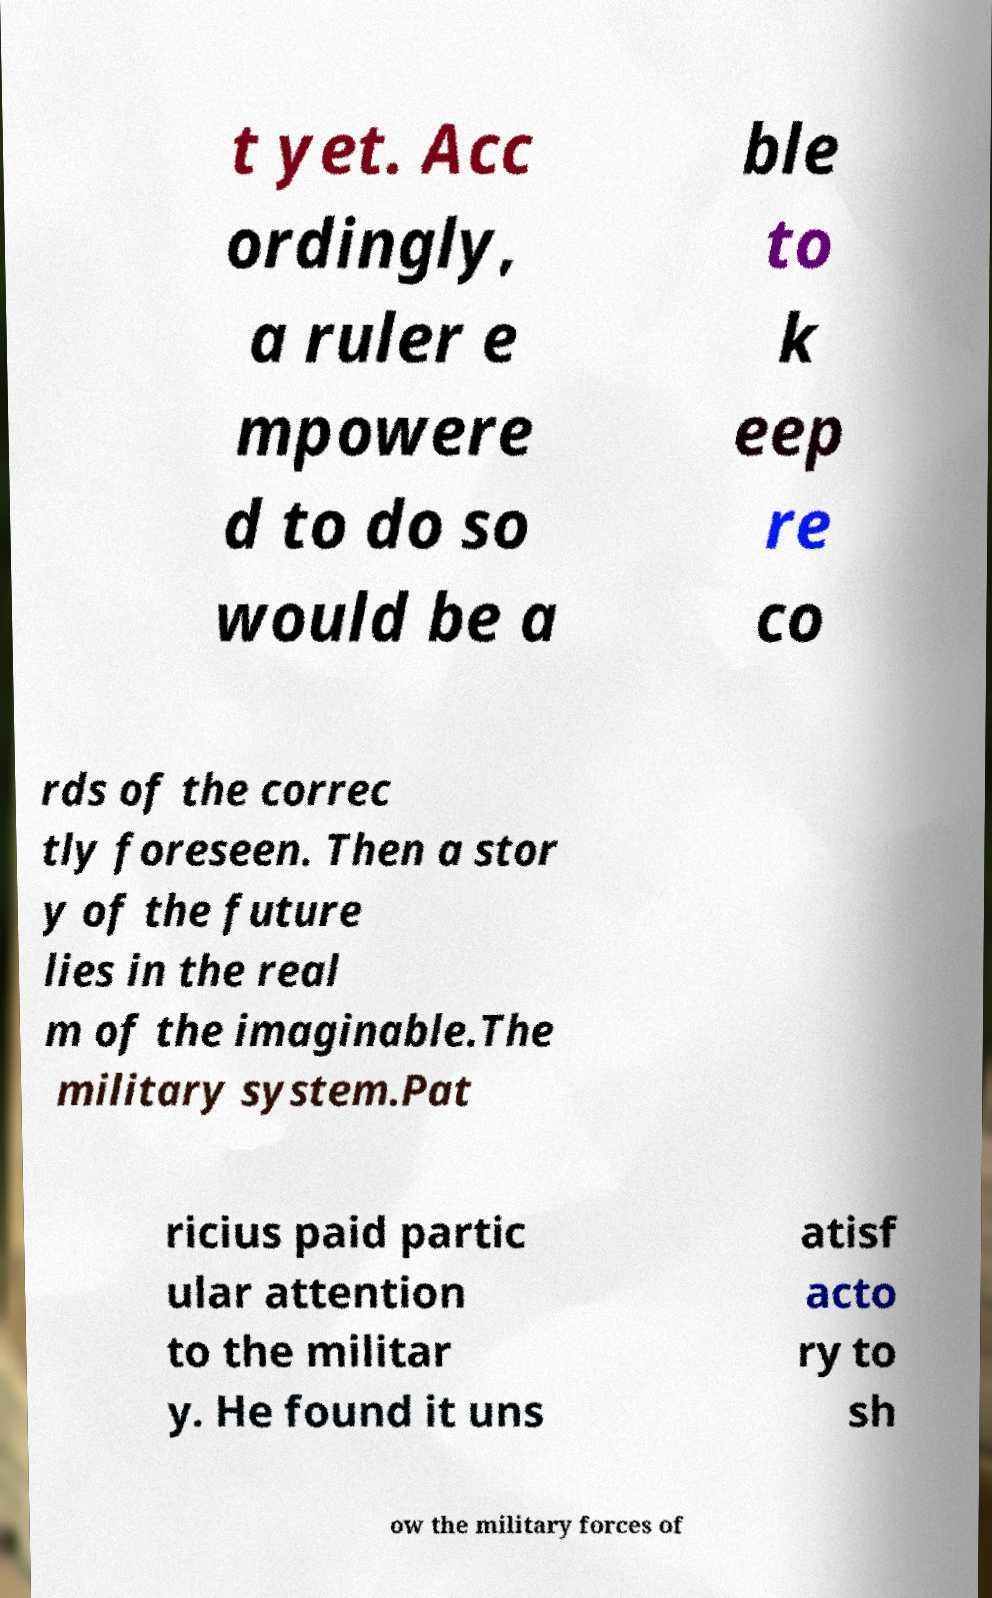I need the written content from this picture converted into text. Can you do that? t yet. Acc ordingly, a ruler e mpowere d to do so would be a ble to k eep re co rds of the correc tly foreseen. Then a stor y of the future lies in the real m of the imaginable.The military system.Pat ricius paid partic ular attention to the militar y. He found it uns atisf acto ry to sh ow the military forces of 